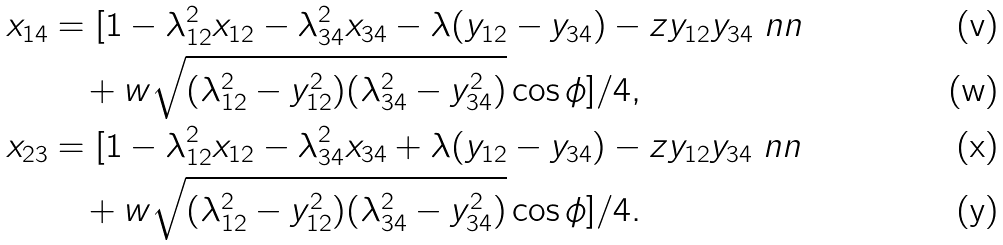<formula> <loc_0><loc_0><loc_500><loc_500>x _ { 1 4 } & = [ 1 - \lambda _ { 1 2 } ^ { 2 } x _ { 1 2 } - \lambda _ { 3 4 } ^ { 2 } x _ { 3 4 } - \lambda ( y _ { 1 2 } - y _ { 3 4 } ) - z y _ { 1 2 } y _ { 3 4 } \ n n \\ & \quad + w \sqrt { ( \lambda _ { 1 2 } ^ { 2 } - y _ { 1 2 } ^ { 2 } ) ( \lambda _ { 3 4 } ^ { 2 } - y _ { 3 4 } ^ { 2 } ) } \cos { \phi } ] / 4 , \\ x _ { 2 3 } & = [ 1 - \lambda _ { 1 2 } ^ { 2 } x _ { 1 2 } - \lambda _ { 3 4 } ^ { 2 } x _ { 3 4 } + \lambda ( y _ { 1 2 } - y _ { 3 4 } ) - z y _ { 1 2 } y _ { 3 4 } \ n n \\ & \quad + w \sqrt { ( \lambda _ { 1 2 } ^ { 2 } - y _ { 1 2 } ^ { 2 } ) ( \lambda _ { 3 4 } ^ { 2 } - y _ { 3 4 } ^ { 2 } ) } \cos { \phi } ] / 4 .</formula> 